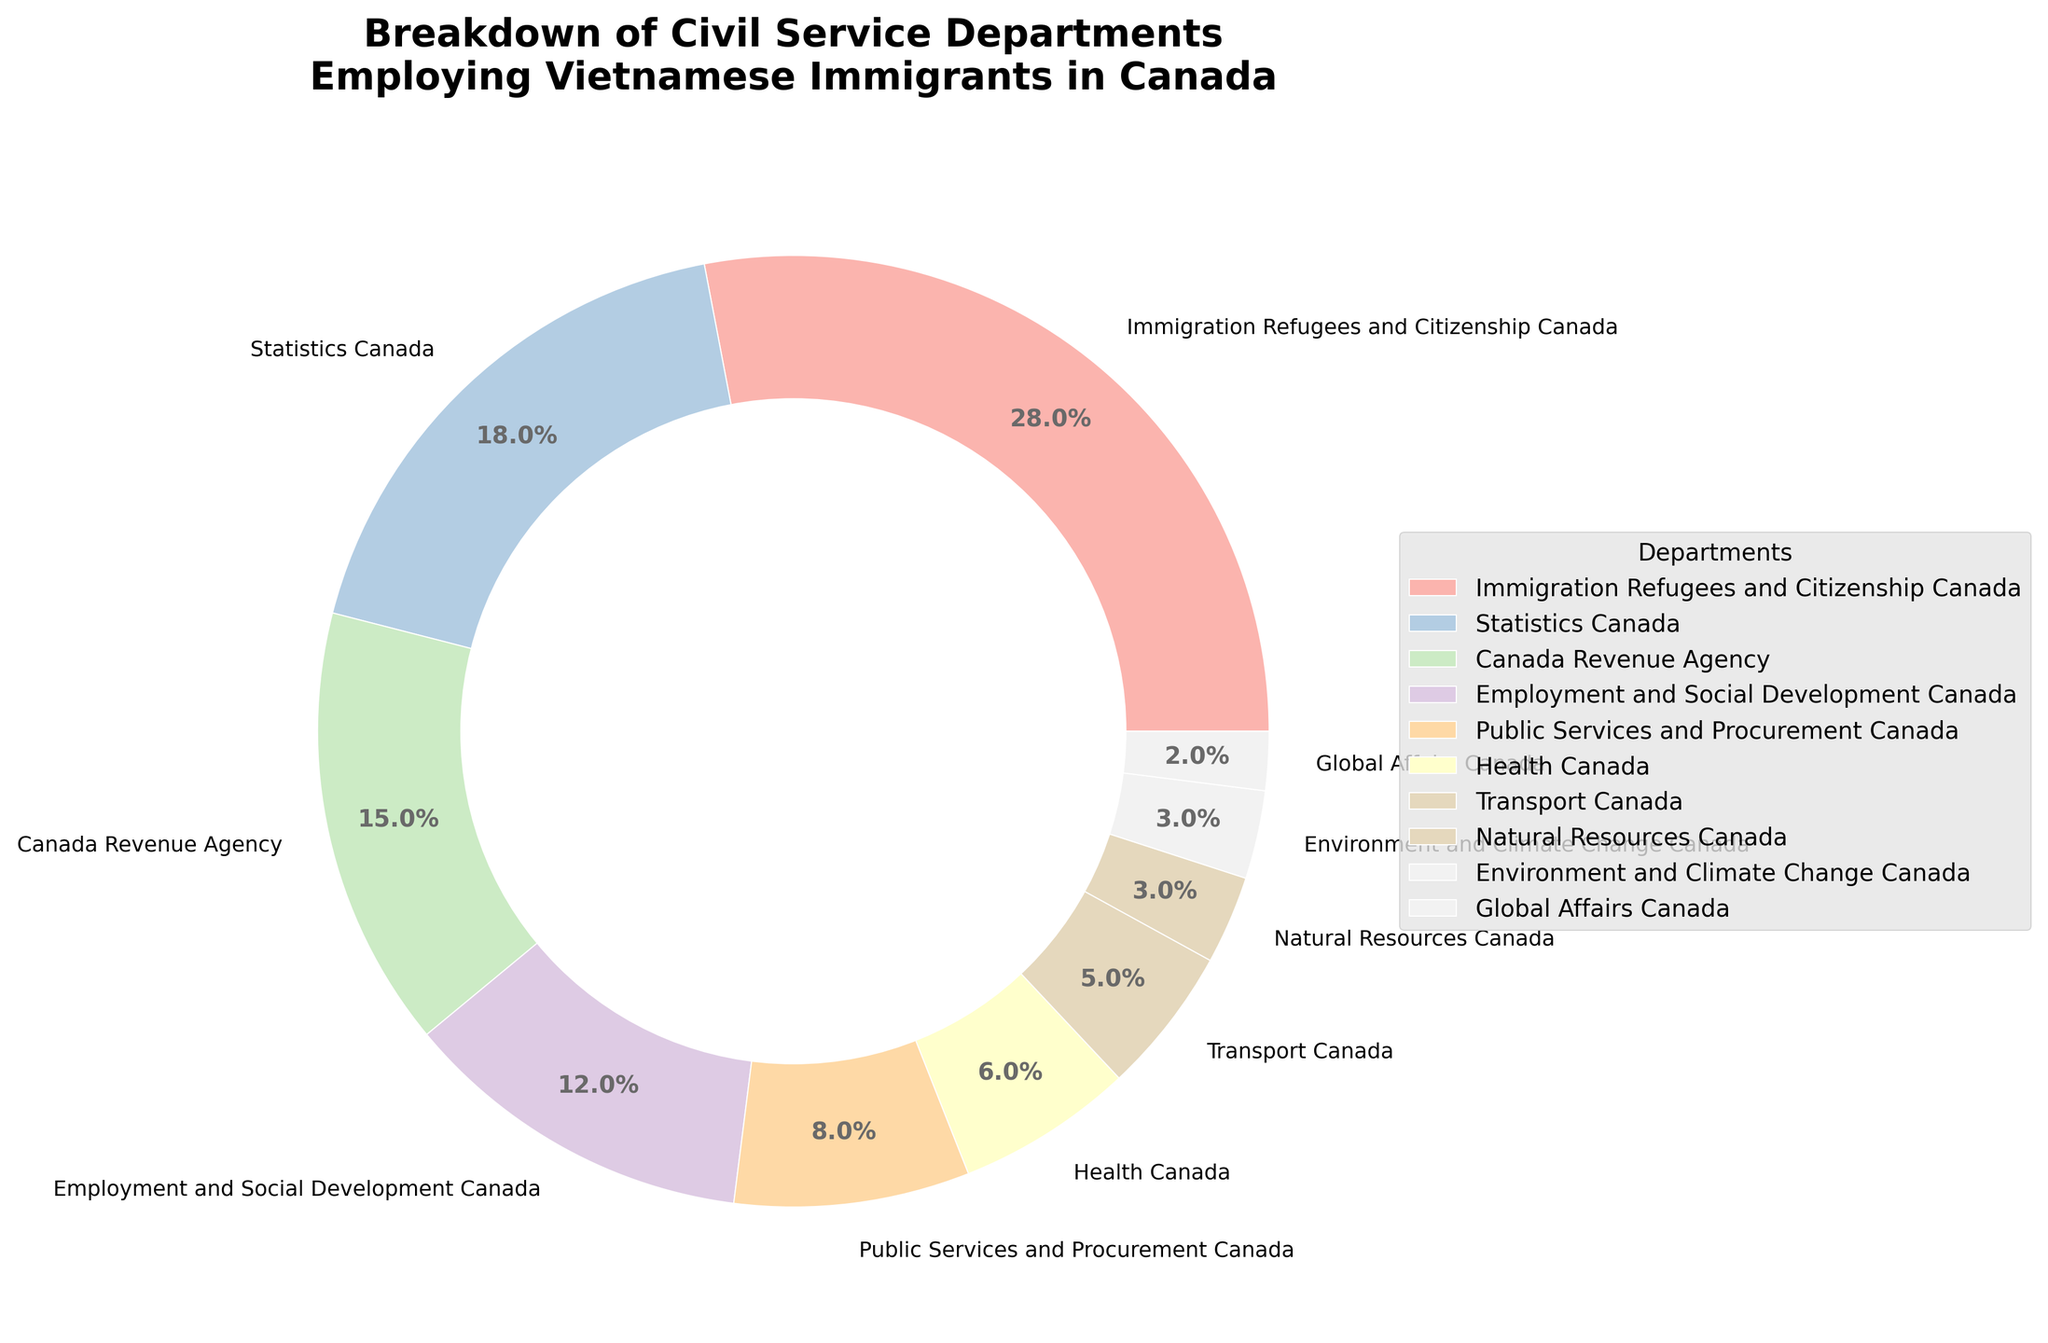What percentage of Vietnamese immigrants work in Immigration Refugees and Citizenship Canada? The segment for "Immigration Refugees and Citizenship Canada" in the pie chart is labeled with the percentage directly.
Answer: 28% Is Canada Revenue Agency employing more or less Vietnamese immigrants than Statistics Canada? By comparing the proportions in the pie chart, Canada Revenue Agency employs 15% while Statistics Canada employs 18%. Thus, Canada Revenue Agency employs fewer Vietnamese immigrants than Statistics Canada.
Answer: Less What is the combined percentage of Vietnamese immigrants employed by Health Canada and Transport Canada? Health Canada employs 6% and Transport Canada employs 5%. Adding these together: 6% + 5% = 11%.
Answer: 11% Which department employs the least number of Vietnamese immigrants? The smallest slice in the pie chart represents Global Affairs Canada, labeled 2%.
Answer: Global Affairs Canada Compare the employment proportions between Employment and Social Development Canada and Public Services and Procurement Canada. Employment and Social Development Canada has a proportion of 12%, while Public Services and Procurement Canada has 8%. Hence, Employment and Social Development Canada employs more Vietnamese immigrants than Public Services and Procurement Canada.
Answer: Employment and Social Development Canada What is the difference in employment percentages between the department with the most and the department with the least Vietnamese immigrants? The department with the most Vietnamese immigrants is Immigration Refugees and Citizenship Canada at 28%, and the one with the least is Global Affairs Canada at 2%. The difference is 28% - 2% = 26%.
Answer: 26% Which sector's segment is visually located next to Canada Revenue Agency in the pie chart? To identify sectors visually adjacent to Canada Revenue Agency's 15% slice, one must look at the neighboring segments in the circular layout, discovering Immigration Refugees and Citizenship Canada on one side and Employment and Social Development Canada on the other side.
Answer: Immigration Refugees and Citizenship Canada and Employment and Social Development Canada How many departments employ less than 10% of Vietnamese immigrants each? By observing the segments under 10%, we identify: Public Services and Procurement Canada (8%), Health Canada (6%), Transport Canada (5%), Natural Resources Canada (3%), Environment and Climate Change Canada (3%), Global Affairs Canada (2%). A total of 6 departments meet this criterion.
Answer: 6 If Health Canada and Natural Resources Canada were combined, where would they rank in terms of percentage of Vietnamese immigrants employed? Adding their percentages: Health Canada (6%) + Natural Resources Canada (3%) = 9%. This combined department would have 9%, placing it between Public Services and Procurement Canada (8%) and Employment and Social Development Canada (12%) in rank.
Answer: Between Public Services and Procurement Canada and Employment and Social Development Canada 